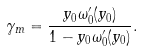<formula> <loc_0><loc_0><loc_500><loc_500>\gamma _ { m } = \frac { y _ { 0 } \omega _ { 0 } ^ { \prime } ( y _ { 0 } ) } { 1 - y _ { 0 } \omega _ { 0 } ^ { \prime } ( y _ { 0 } ) } .</formula> 